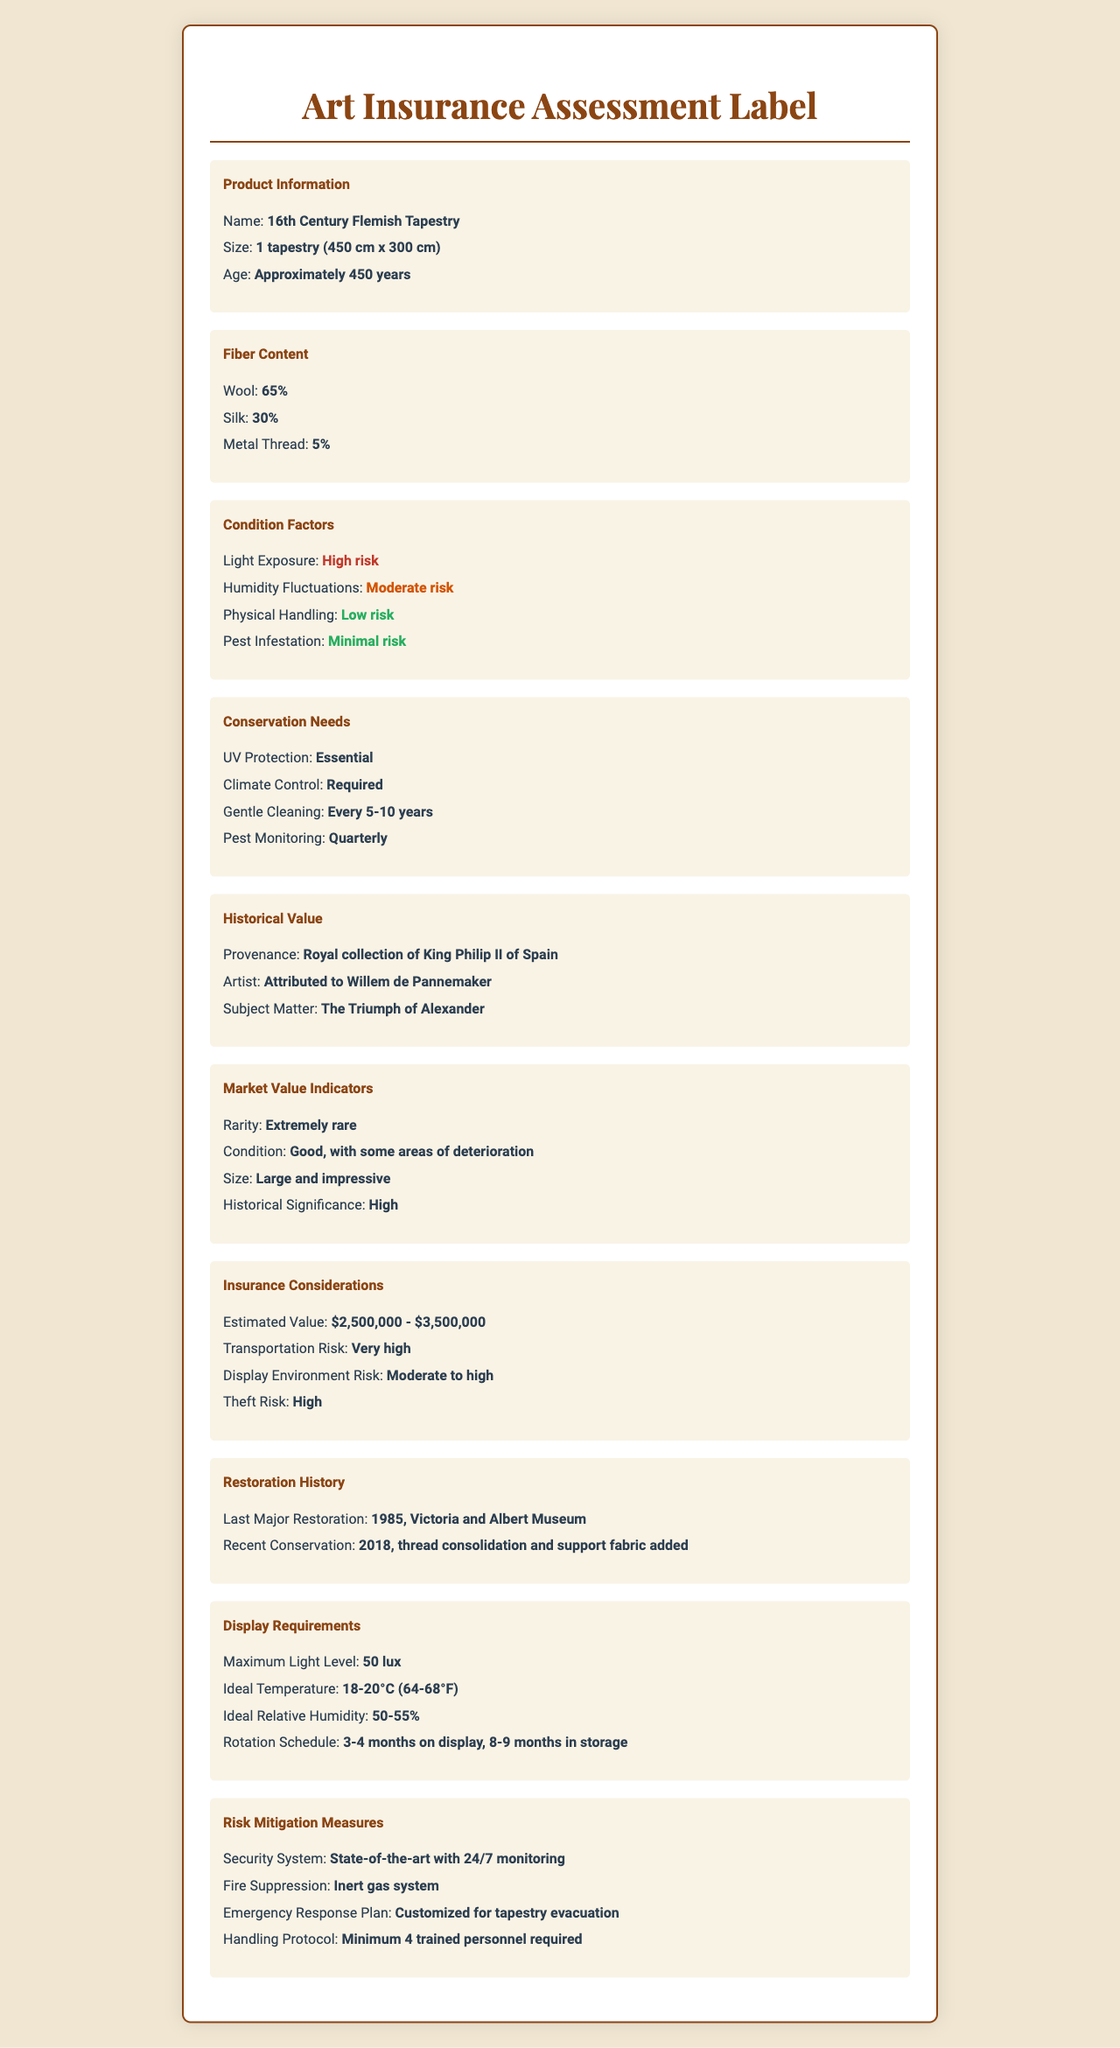what is the age of the tapestry? The age of the tapestry is listed as approximately 450 years.
Answer: Approximately 450 years which types of fibers are used in the tapestry? The Fiber Content section lists Wool (65%), Silk (30%), and Metal Thread (5%).
Answer: Wool, Silk, and Metal Thread what level of risk does light exposure pose to the tapestry? The Condition Factors section indicates that Light Exposure poses a High risk.
Answer: High risk how frequently should gentle cleaning be performed on the tapestry? The Conservation Needs section recommends gentle cleaning every 5-10 years.
Answer: Every 5-10 years where was the last major restoration of the tapestry conducted? The Restoration History section states that the last major restoration was in 1985 at the Victoria and Albert Museum.
Answer: Victoria and Albert Museum who is the artist attributed to the tapestry? The Historical Value section mentions that the artist is attributed to Willem de Pannemaker.
Answer: Willem de Pannemaker what is the estimated value of the tapestry? The Insurance Considerations section provides an estimated value of $2,500,000 to $3,500,000.
Answer: $2,500,000 - $3,500,000 what temperature range is ideal for displaying the tapestry? The Display Requirements section specifies an ideal temperature range of 18-20°C (64-68°F).
Answer: 18-20°C (64-68°F) which of the following is essential for the conservation of the tapestry? A. Humidity control B. UV protection C. Regular washing UV Protection is listed as Essential in the Conservation Needs section.
Answer: B how often should pest monitoring be conducted? The Conservation Needs section advises quarterly pest monitoring.
Answer: Quarterly is the tapestry considered easy to handle based on physical handling risk? The Condition Factors section indicates that the Physical Handling risk is Low, making it relatively easy to handle.
Answer: Yes summarize the main conservation needs of the tapestry. The Conservation Needs section highlights that the tapestry requires essential UV protection, required climate control, gentle cleaning every 5-10 years, and quarterly pest monitoring.
Answer: UV protection, climate control, gentle cleaning every 5-10 years, and quarterly pest monitoring what type of security system is installed for the tapestry's risk mitigation? The Risk Mitigation Measures section mentions a state-of-the-art security system with 24/7 monitoring.
Answer: State-of-the-art system with 24/7 monitoring how is the provenance of the tapestry described? The Historical Value section states that the tapestry is from the royal collection of King Philip II of Spain.
Answer: Royal collection of King Philip II of Spain how often should the tapestry be rotated between display and storage? The Display Requirements section suggests a rotation schedule of 3-4 months on display and 8-9 months in storage.
Answer: 3-4 months on display, 8-9 months in storage what is the subject matter of the tapestry? A. The battle of Hastings B. The coronation of Charlemagne C. The Triumph of Alexander The Historical Value section specifies that the subject matter is The Triumph of Alexander.
Answer: C what is the condition of the tapestry? The Market Value Indicators section describes the condition as Good, with some areas of deterioration.
Answer: Good, with some areas of deterioration what security measures are in place for fire suppression? The Risk Mitigation Measures section lists a fire suppression system using inert gas.
Answer: Inert gas system when was the most recent conservation effort made? The Restoration History section states that the most recent conservation was done in 2018.
Answer: 2018 what prints are used for non-visible information in the document? The document does not provide information on prints or methods of non-visible information management.
Answer: Cannot be determined 